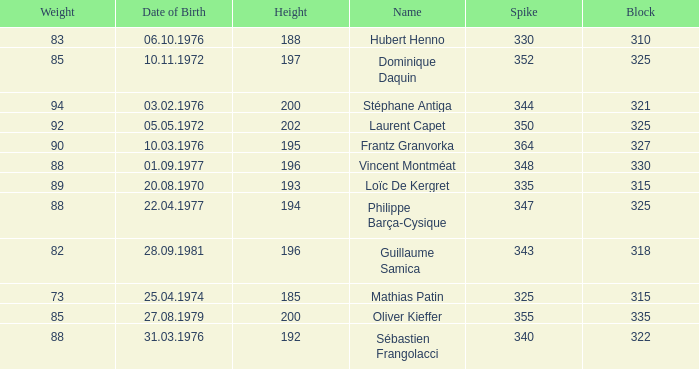I'm looking to parse the entire table for insights. Could you assist me with that? {'header': ['Weight', 'Date of Birth', 'Height', 'Name', 'Spike', 'Block'], 'rows': [['83', '06.10.1976', '188', 'Hubert Henno', '330', '310'], ['85', '10.11.1972', '197', 'Dominique Daquin', '352', '325'], ['94', '03.02.1976', '200', 'Stéphane Antiga', '344', '321'], ['92', '05.05.1972', '202', 'Laurent Capet', '350', '325'], ['90', '10.03.1976', '195', 'Frantz Granvorka', '364', '327'], ['88', '01.09.1977', '196', 'Vincent Montméat', '348', '330'], ['89', '20.08.1970', '193', 'Loïc De Kergret', '335', '315'], ['88', '22.04.1977', '194', 'Philippe Barça-Cysique', '347', '325'], ['82', '28.09.1981', '196', 'Guillaume Samica', '343', '318'], ['73', '25.04.1974', '185', 'Mathias Patin', '325', '315'], ['85', '27.08.1979', '200', 'Oliver Kieffer', '355', '335'], ['88', '31.03.1976', '192', 'Sébastien Frangolacci', '340', '322']]} How many spikes have 28.09.1981 as the date of birth, with a block greater than 318? None. 